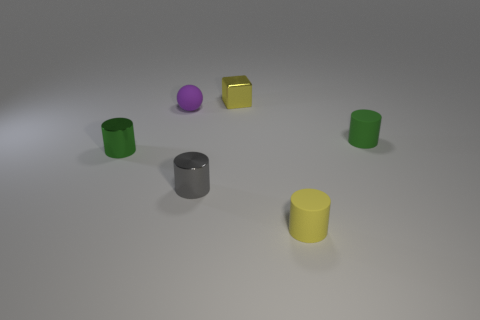What number of tiny green objects are behind the small metallic object on the left side of the tiny gray cylinder?
Make the answer very short. 1. How many things are either rubber cylinders in front of the tiny gray thing or small cylinders that are to the left of the gray shiny thing?
Provide a short and direct response. 2. There is a yellow object that is the same shape as the gray thing; what is it made of?
Your answer should be very brief. Rubber. How many things are tiny yellow cylinders that are to the right of the gray thing or tiny matte cylinders?
Your response must be concise. 2. What shape is the purple object that is the same material as the small yellow cylinder?
Provide a succinct answer. Sphere. What number of purple objects have the same shape as the tiny yellow matte object?
Provide a succinct answer. 0. What material is the cube?
Make the answer very short. Metal. Do the tiny shiny cube and the object that is in front of the small gray metallic thing have the same color?
Your answer should be very brief. Yes. What number of cylinders are either small green things or big red rubber objects?
Make the answer very short. 2. What color is the tiny matte object in front of the tiny green metal cylinder?
Provide a succinct answer. Yellow. 